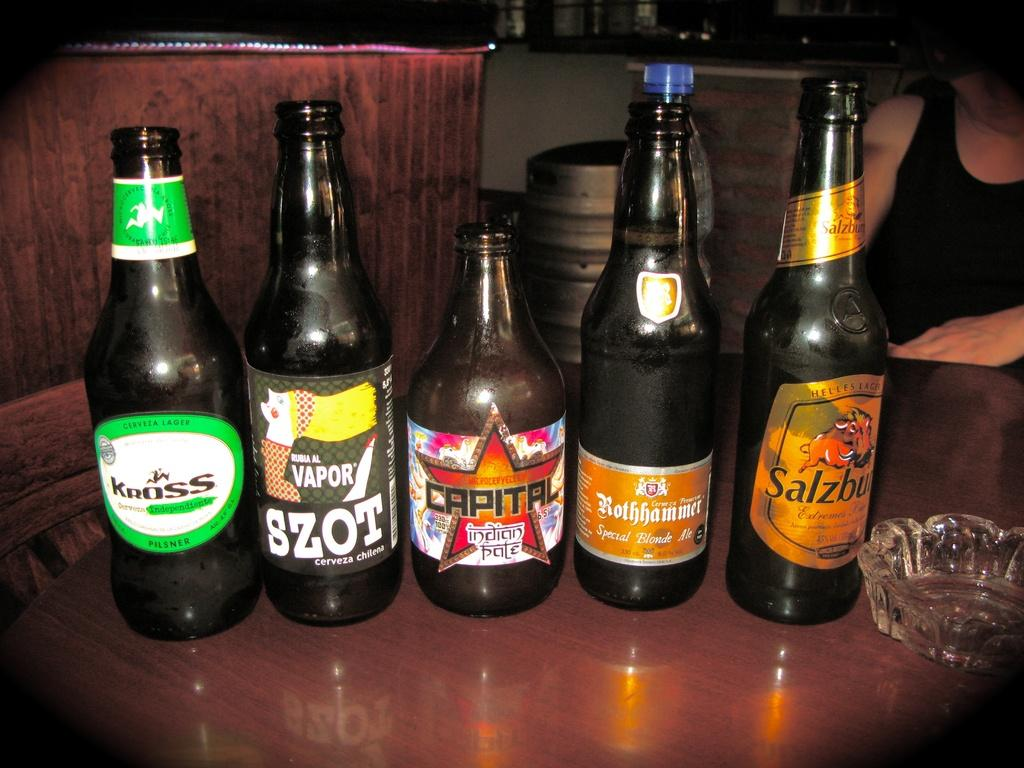How many bottles with labels can be seen in the image? There are five bottles with labels in the image. What other object is present on the table with the bottles? There is an ashtray in the image. Where are the bottles and ashtray located? The bottles and ashtray are placed on a table. Can you describe the presence of a person in the image? There is a person in the background of the image. What type of lamp is visible on the edge of the table in the image? There is no lamp present on the edge of the table in the image. 